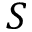<formula> <loc_0><loc_0><loc_500><loc_500>S</formula> 